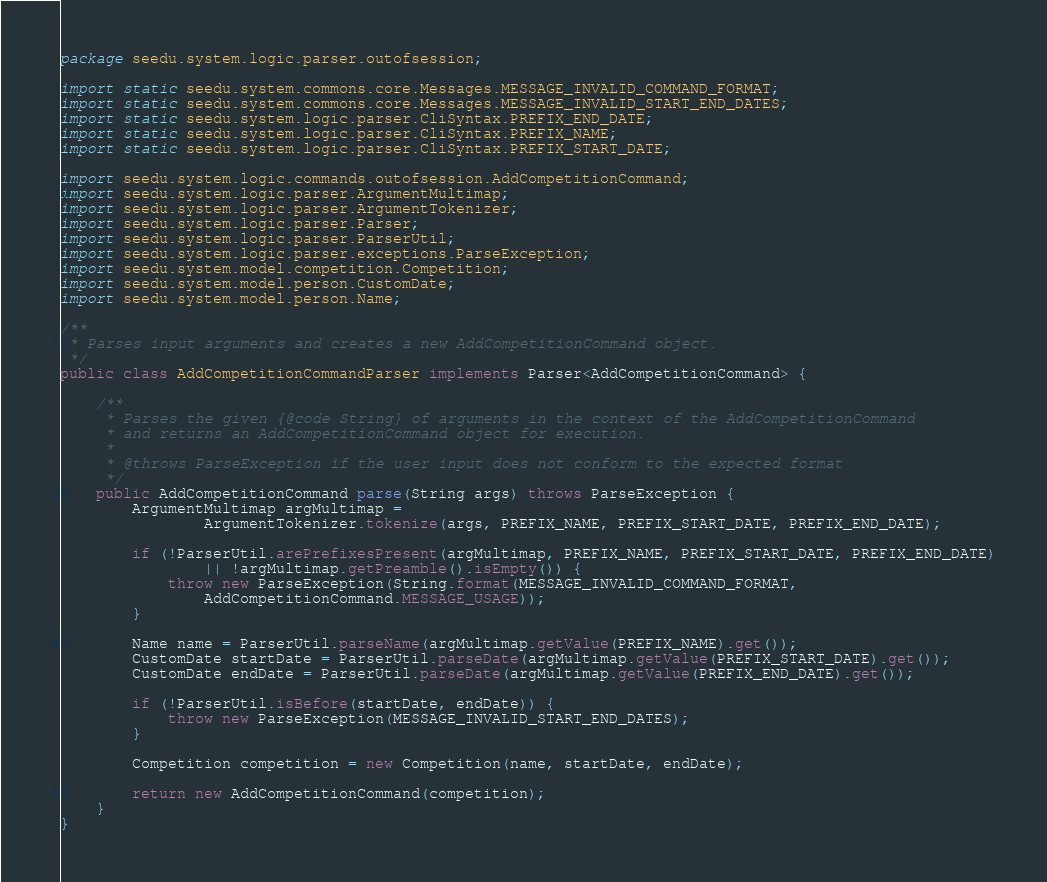Convert code to text. <code><loc_0><loc_0><loc_500><loc_500><_Java_>package seedu.system.logic.parser.outofsession;

import static seedu.system.commons.core.Messages.MESSAGE_INVALID_COMMAND_FORMAT;
import static seedu.system.commons.core.Messages.MESSAGE_INVALID_START_END_DATES;
import static seedu.system.logic.parser.CliSyntax.PREFIX_END_DATE;
import static seedu.system.logic.parser.CliSyntax.PREFIX_NAME;
import static seedu.system.logic.parser.CliSyntax.PREFIX_START_DATE;

import seedu.system.logic.commands.outofsession.AddCompetitionCommand;
import seedu.system.logic.parser.ArgumentMultimap;
import seedu.system.logic.parser.ArgumentTokenizer;
import seedu.system.logic.parser.Parser;
import seedu.system.logic.parser.ParserUtil;
import seedu.system.logic.parser.exceptions.ParseException;
import seedu.system.model.competition.Competition;
import seedu.system.model.person.CustomDate;
import seedu.system.model.person.Name;

/**
 * Parses input arguments and creates a new AddCompetitionCommand object.
 */
public class AddCompetitionCommandParser implements Parser<AddCompetitionCommand> {

    /**
     * Parses the given {@code String} of arguments in the context of the AddCompetitionCommand
     * and returns an AddCompetitionCommand object for execution.
     *
     * @throws ParseException if the user input does not conform to the expected format
     */
    public AddCompetitionCommand parse(String args) throws ParseException {
        ArgumentMultimap argMultimap =
                ArgumentTokenizer.tokenize(args, PREFIX_NAME, PREFIX_START_DATE, PREFIX_END_DATE);

        if (!ParserUtil.arePrefixesPresent(argMultimap, PREFIX_NAME, PREFIX_START_DATE, PREFIX_END_DATE)
                || !argMultimap.getPreamble().isEmpty()) {
            throw new ParseException(String.format(MESSAGE_INVALID_COMMAND_FORMAT,
                AddCompetitionCommand.MESSAGE_USAGE));
        }

        Name name = ParserUtil.parseName(argMultimap.getValue(PREFIX_NAME).get());
        CustomDate startDate = ParserUtil.parseDate(argMultimap.getValue(PREFIX_START_DATE).get());
        CustomDate endDate = ParserUtil.parseDate(argMultimap.getValue(PREFIX_END_DATE).get());

        if (!ParserUtil.isBefore(startDate, endDate)) {
            throw new ParseException(MESSAGE_INVALID_START_END_DATES);
        }

        Competition competition = new Competition(name, startDate, endDate);

        return new AddCompetitionCommand(competition);
    }
}
</code> 